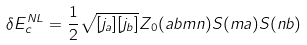Convert formula to latex. <formula><loc_0><loc_0><loc_500><loc_500>\delta E ^ { N L } _ { c } = \frac { 1 } { 2 } \sqrt { [ j _ { a } ] [ j _ { b } ] } Z _ { 0 } ( a b m n ) S ( m a ) S ( n b )</formula> 